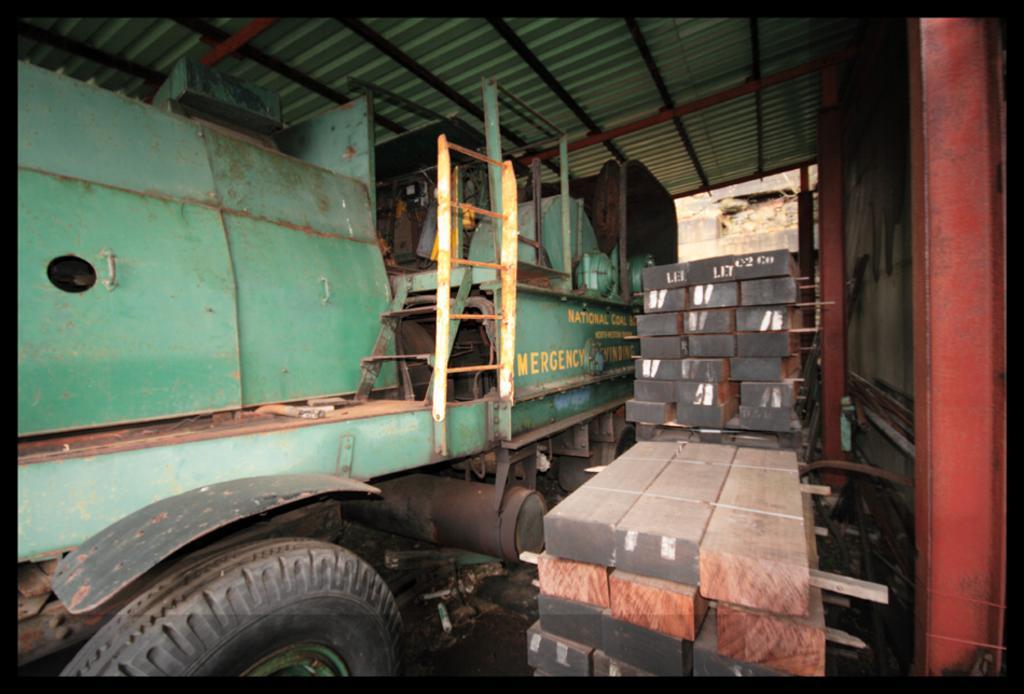How would you summarize this image in a sentence or two? In this picture, we see a vehicle in green color. Beside that, we see the wooden blocks and sticks. On the right side, we see a wall and the poles. At the top, we see the roof of the shed. In the background, we see a wall. 